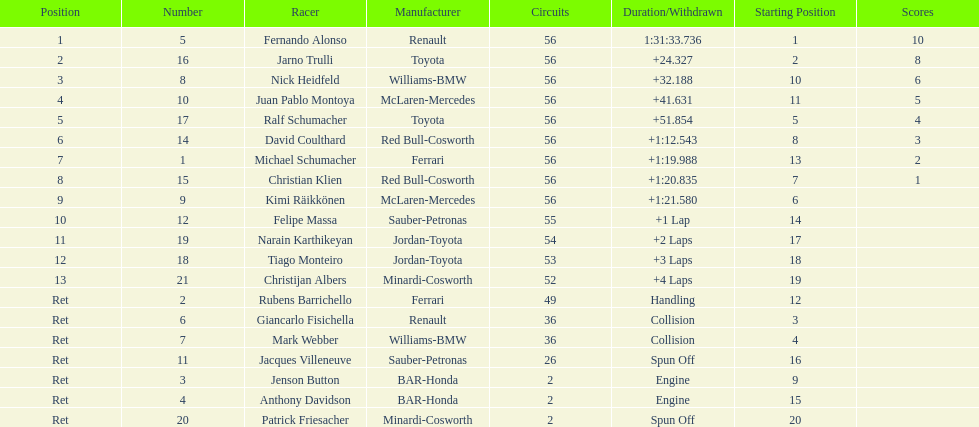What driver finished first? Fernando Alonso. 